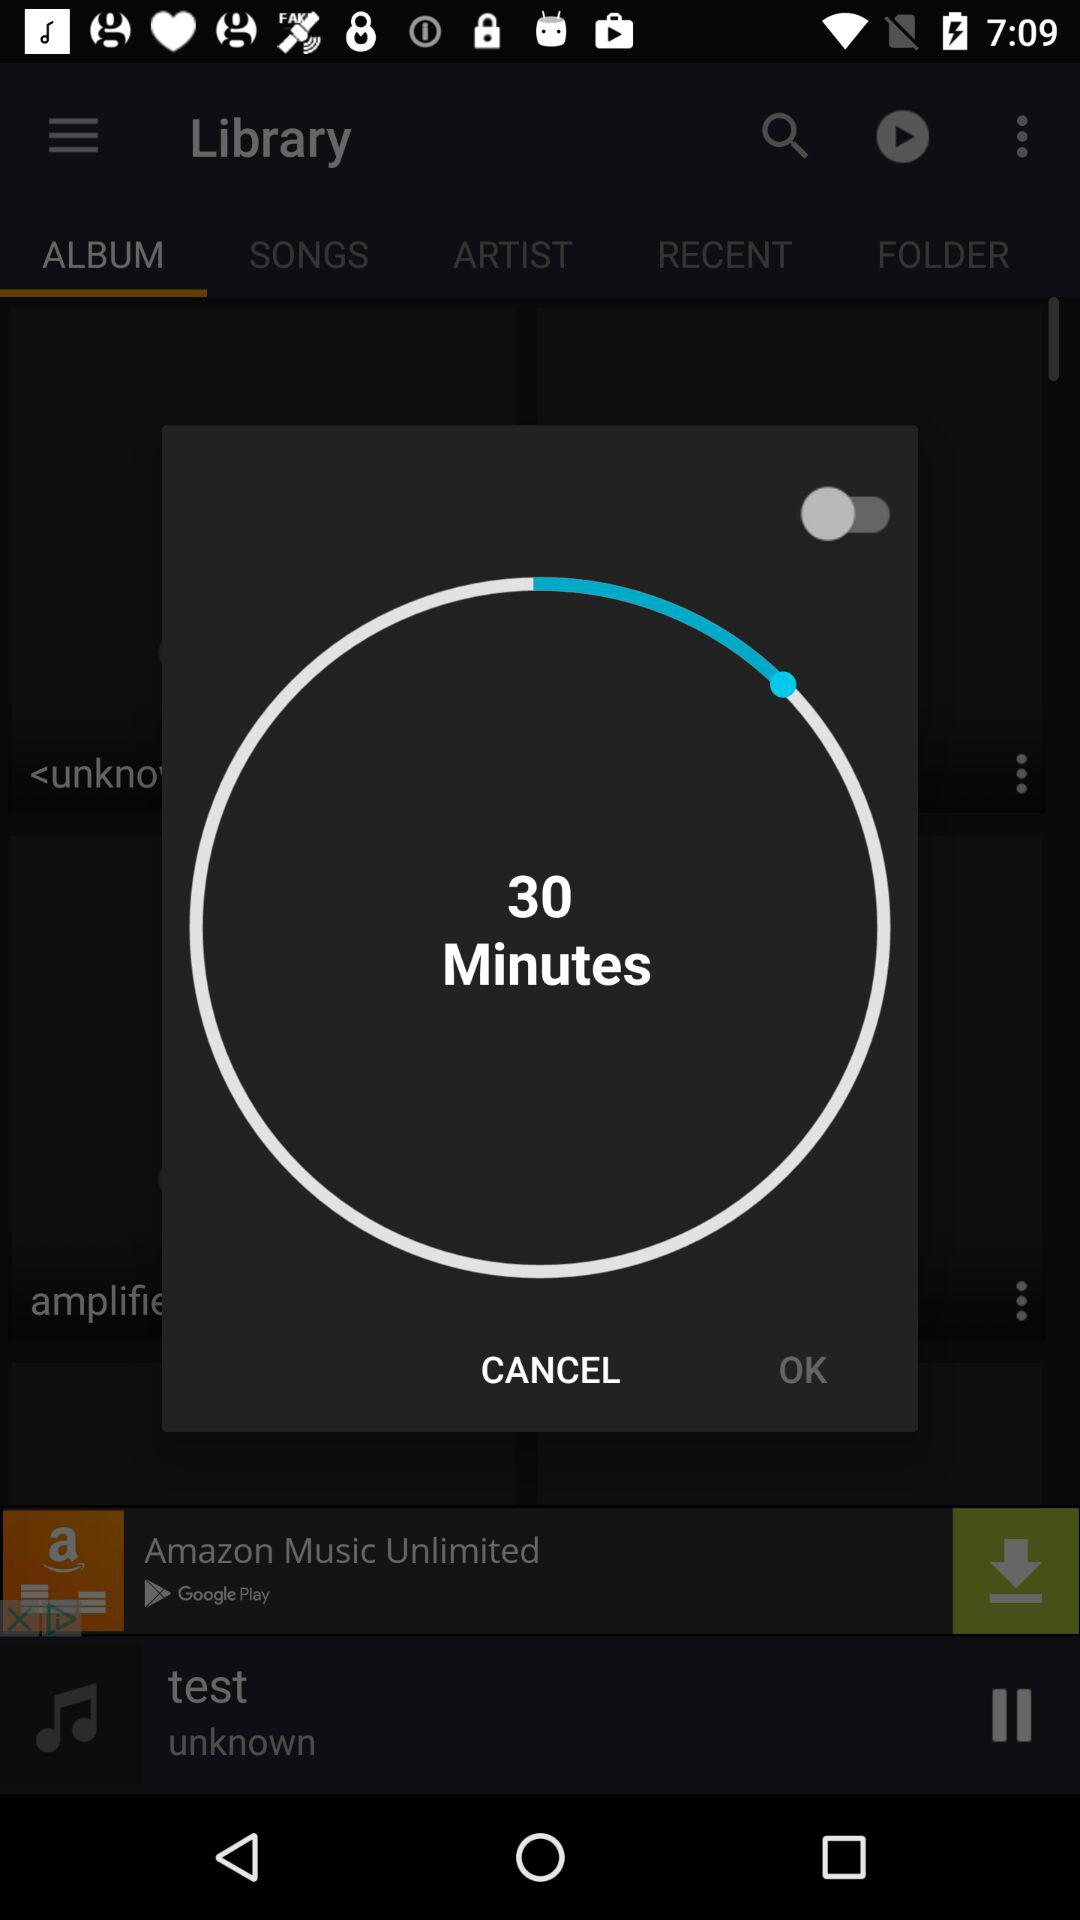What is the remaining time? The remaining time is 30 minutes. 